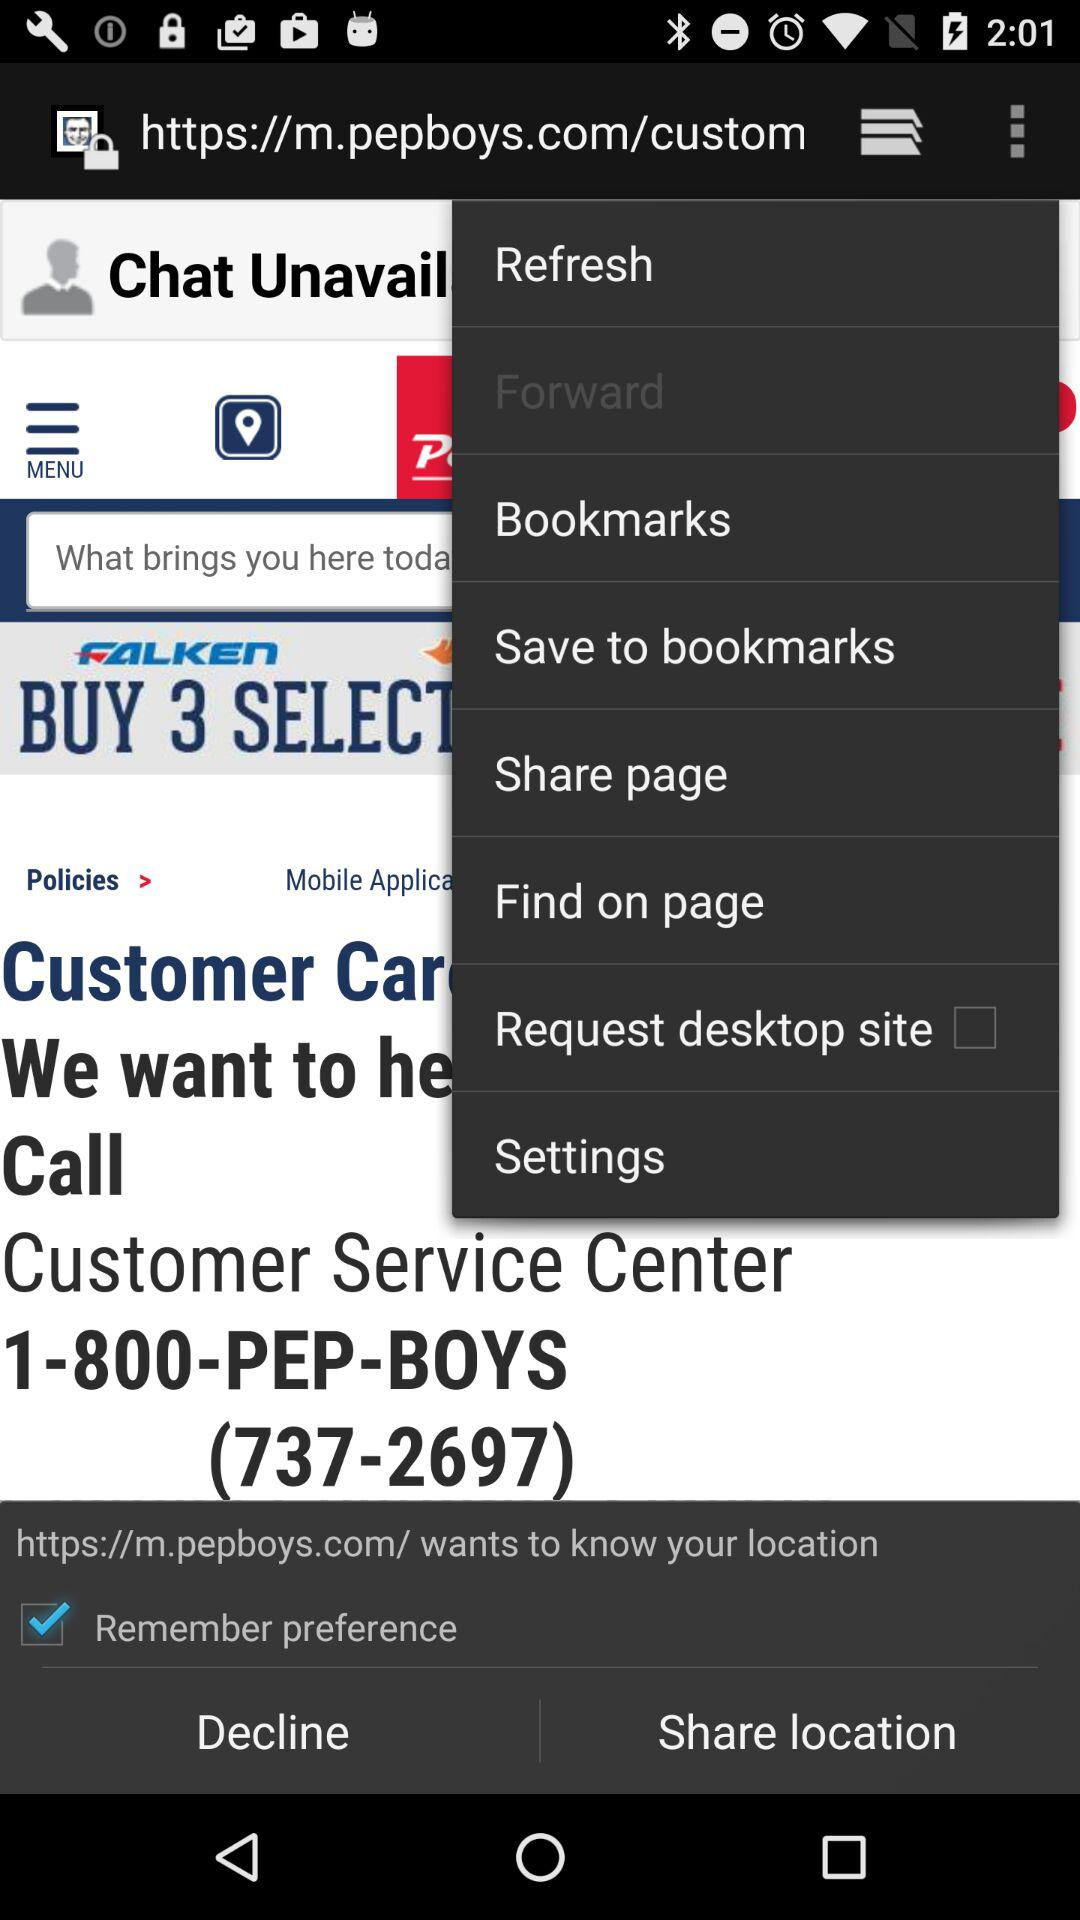What is the status of "Remember preference"? The status of "Remember preference" is "on". 